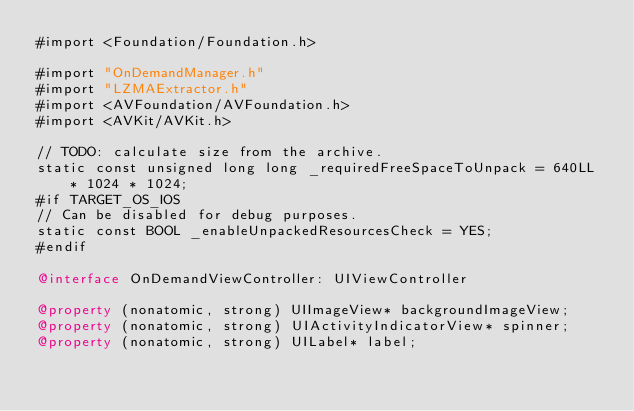<code> <loc_0><loc_0><loc_500><loc_500><_ObjectiveC_>#import <Foundation/Foundation.h>

#import "OnDemandManager.h"
#import "LZMAExtractor.h"
#import <AVFoundation/AVFoundation.h>
#import <AVKit/AVKit.h>

// TODO: calculate size from the archive.
static const unsigned long long _requiredFreeSpaceToUnpack = 640LL * 1024 * 1024;
#if TARGET_OS_IOS
// Can be disabled for debug purposes.
static const BOOL _enableUnpackedResourcesCheck = YES;
#endif

@interface OnDemandViewController: UIViewController

@property (nonatomic, strong) UIImageView* backgroundImageView;
@property (nonatomic, strong) UIActivityIndicatorView* spinner;
@property (nonatomic, strong) UILabel* label;</code> 